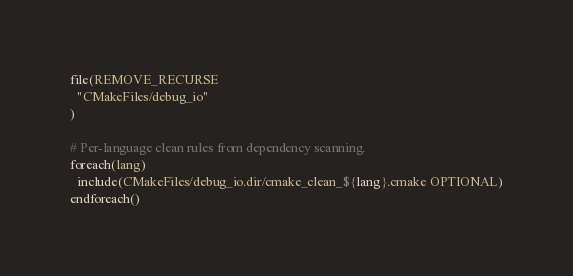<code> <loc_0><loc_0><loc_500><loc_500><_CMake_>file(REMOVE_RECURSE
  "CMakeFiles/debug_io"
)

# Per-language clean rules from dependency scanning.
foreach(lang)
  include(CMakeFiles/debug_io.dir/cmake_clean_${lang}.cmake OPTIONAL)
endforeach()
</code> 